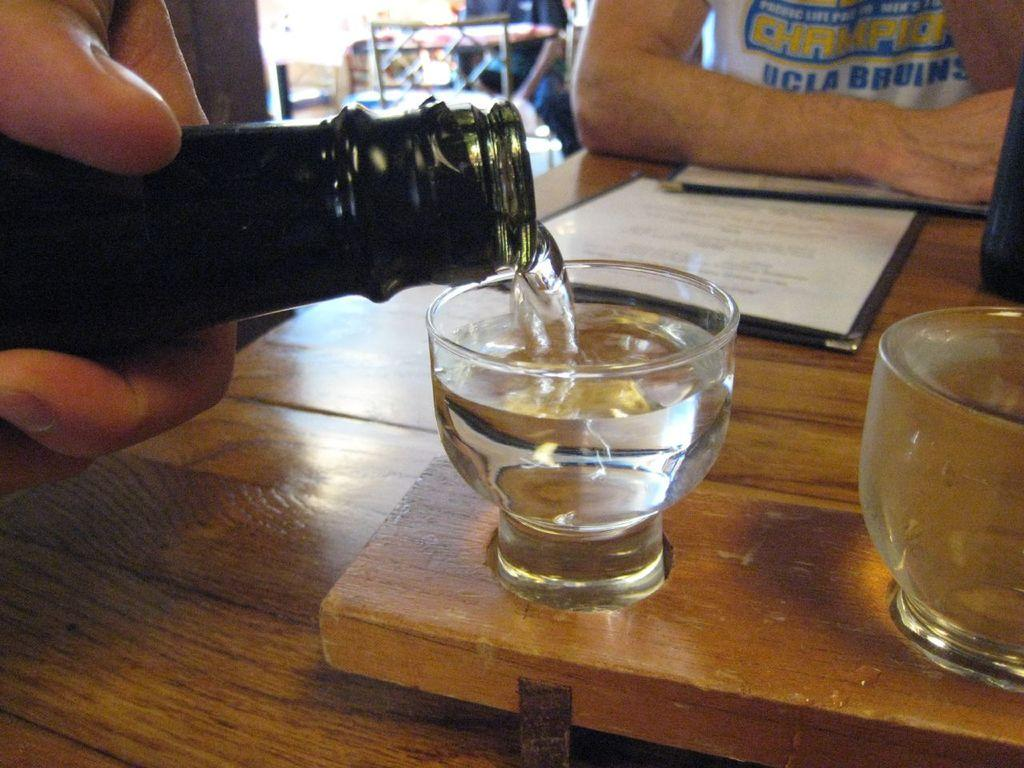Provide a one-sentence caption for the provided image. Champions UCLA Bruins shirt that a man is wearing along with a wine bottle being poured into a small cup. 